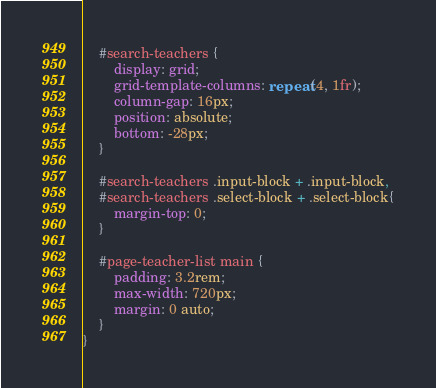<code> <loc_0><loc_0><loc_500><loc_500><_CSS_>
    #search-teachers {
        display: grid;
        grid-template-columns: repeat(4, 1fr);
        column-gap: 16px;
        position: absolute;
        bottom: -28px;
    }

    #search-teachers .input-block + .input-block,
    #search-teachers .select-block + .select-block{
        margin-top: 0;
    }

    #page-teacher-list main {
        padding: 3.2rem;
        max-width: 720px;
        margin: 0 auto;
    }
}
</code> 